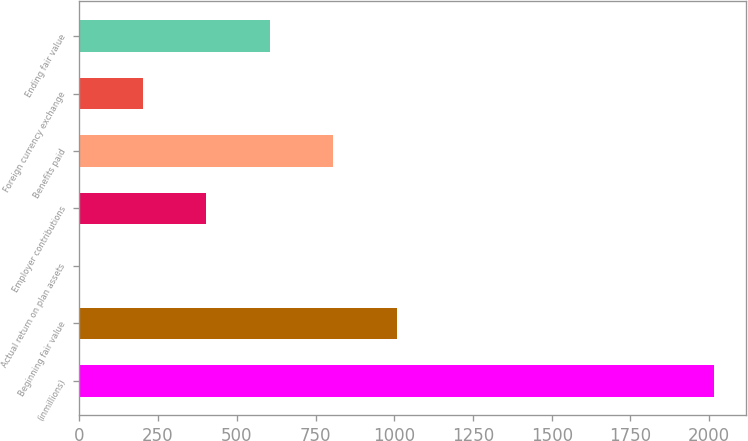Convert chart to OTSL. <chart><loc_0><loc_0><loc_500><loc_500><bar_chart><fcel>(inmillions)<fcel>Beginning fair value<fcel>Actual return on plan assets<fcel>Employer contributions<fcel>Benefits paid<fcel>Foreign currency exchange<fcel>Ending fair value<nl><fcel>2015<fcel>1008<fcel>1<fcel>403.8<fcel>806.6<fcel>202.4<fcel>605.2<nl></chart> 